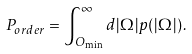Convert formula to latex. <formula><loc_0><loc_0><loc_500><loc_500>P _ { o r d e r } = \int _ { O _ { \min } } ^ { \infty } d | \Omega | \, p ( | \Omega | ) \, .</formula> 